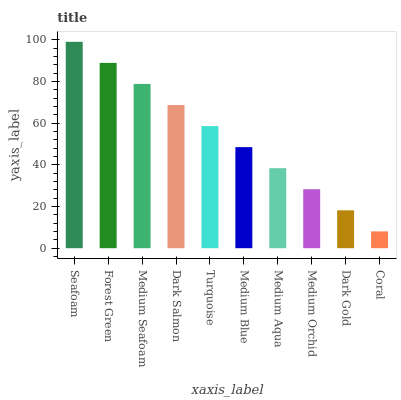Is Coral the minimum?
Answer yes or no. Yes. Is Seafoam the maximum?
Answer yes or no. Yes. Is Forest Green the minimum?
Answer yes or no. No. Is Forest Green the maximum?
Answer yes or no. No. Is Seafoam greater than Forest Green?
Answer yes or no. Yes. Is Forest Green less than Seafoam?
Answer yes or no. Yes. Is Forest Green greater than Seafoam?
Answer yes or no. No. Is Seafoam less than Forest Green?
Answer yes or no. No. Is Turquoise the high median?
Answer yes or no. Yes. Is Medium Blue the low median?
Answer yes or no. Yes. Is Medium Seafoam the high median?
Answer yes or no. No. Is Forest Green the low median?
Answer yes or no. No. 